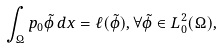Convert formula to latex. <formula><loc_0><loc_0><loc_500><loc_500>\int _ { \Omega } p _ { 0 } \tilde { \phi } \, d x = \ell ( \tilde { \phi } ) , \forall \tilde { \phi } \in L ^ { 2 } _ { 0 } ( \Omega ) ,</formula> 